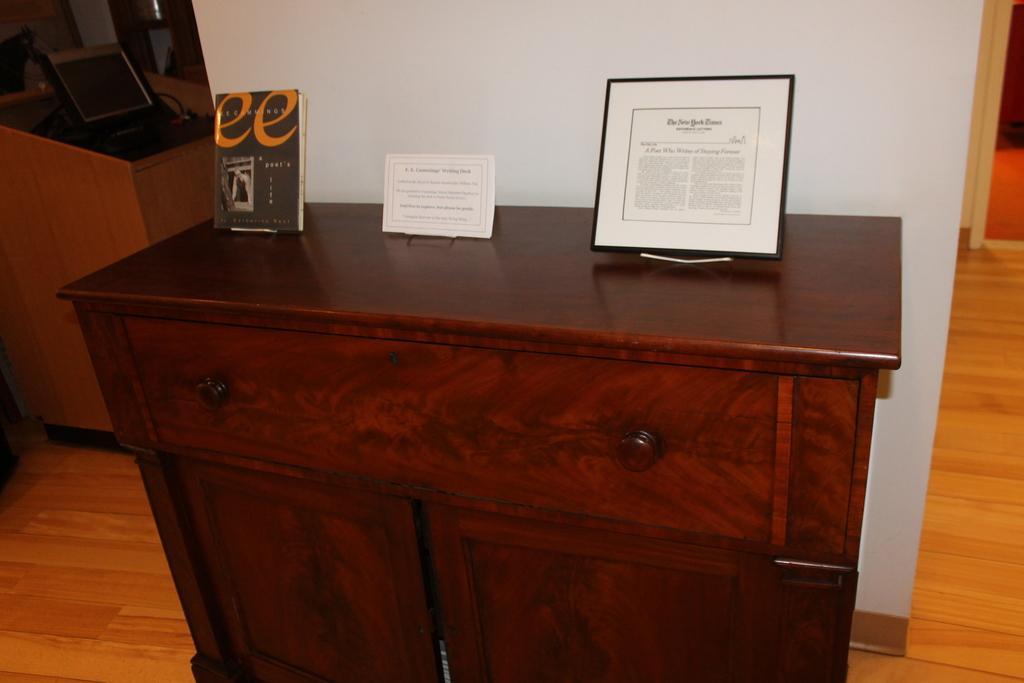Could you give a brief overview of what you see in this image? In this image we can see two photo frame and a book on the desk, there is a laptop on the table, we can also see a white wall, and the wooden floor. 